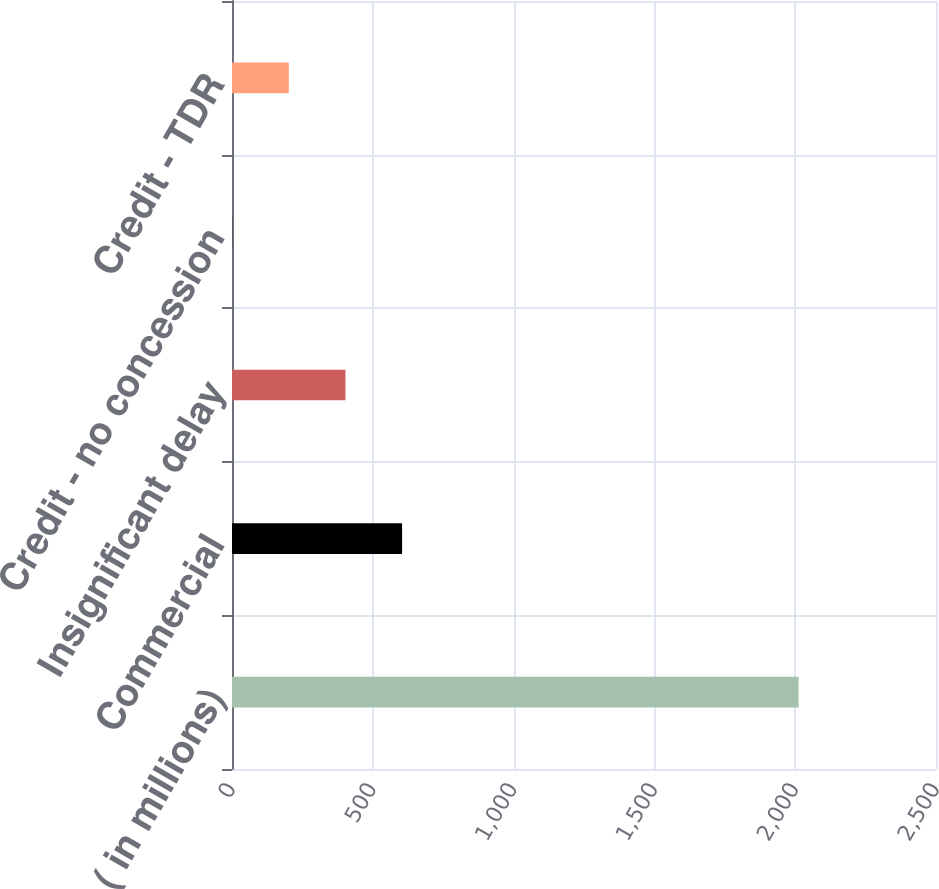Convert chart. <chart><loc_0><loc_0><loc_500><loc_500><bar_chart><fcel>( in millions)<fcel>Commercial<fcel>Insignificant delay<fcel>Credit - no concession<fcel>Credit - TDR<nl><fcel>2012<fcel>604.02<fcel>402.88<fcel>0.6<fcel>201.74<nl></chart> 